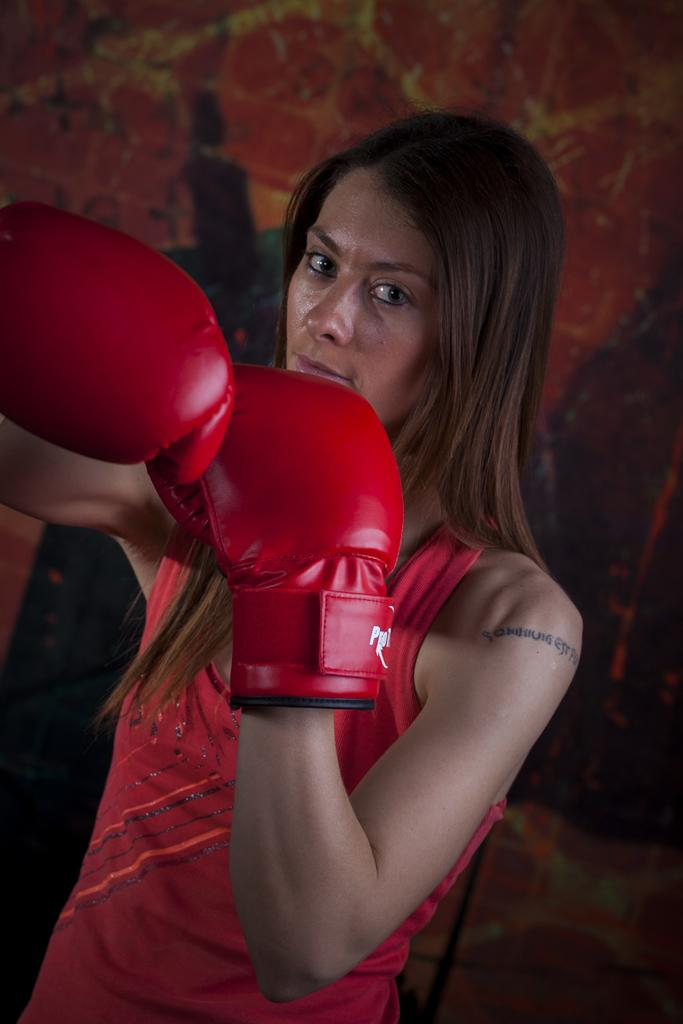Who is the main subject in the image? There is a woman in the image. What is the woman wearing on her hands? The woman is wearing red boxing gloves. Can you describe the background of the image? The background of the woman is blurred. What type of digestion is the woman experiencing in the image? There is no indication of digestion in the image; it features a woman wearing red boxing gloves with a blurred background. 